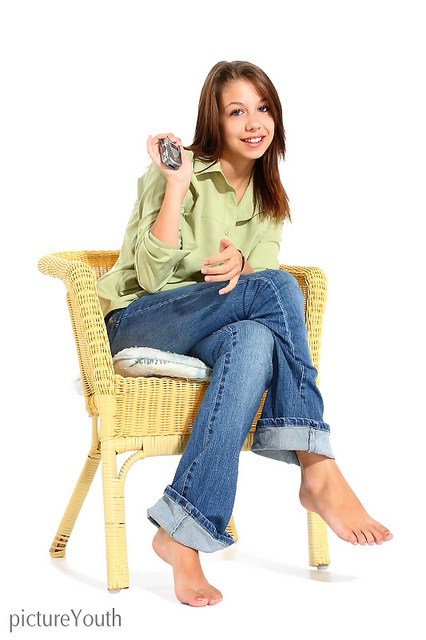Describe the objects in this image and their specific colors. I can see people in white, khaki, gray, tan, and blue tones, chair in white, khaki, ivory, and tan tones, and cell phone in white, darkgray, gray, and lightgray tones in this image. 